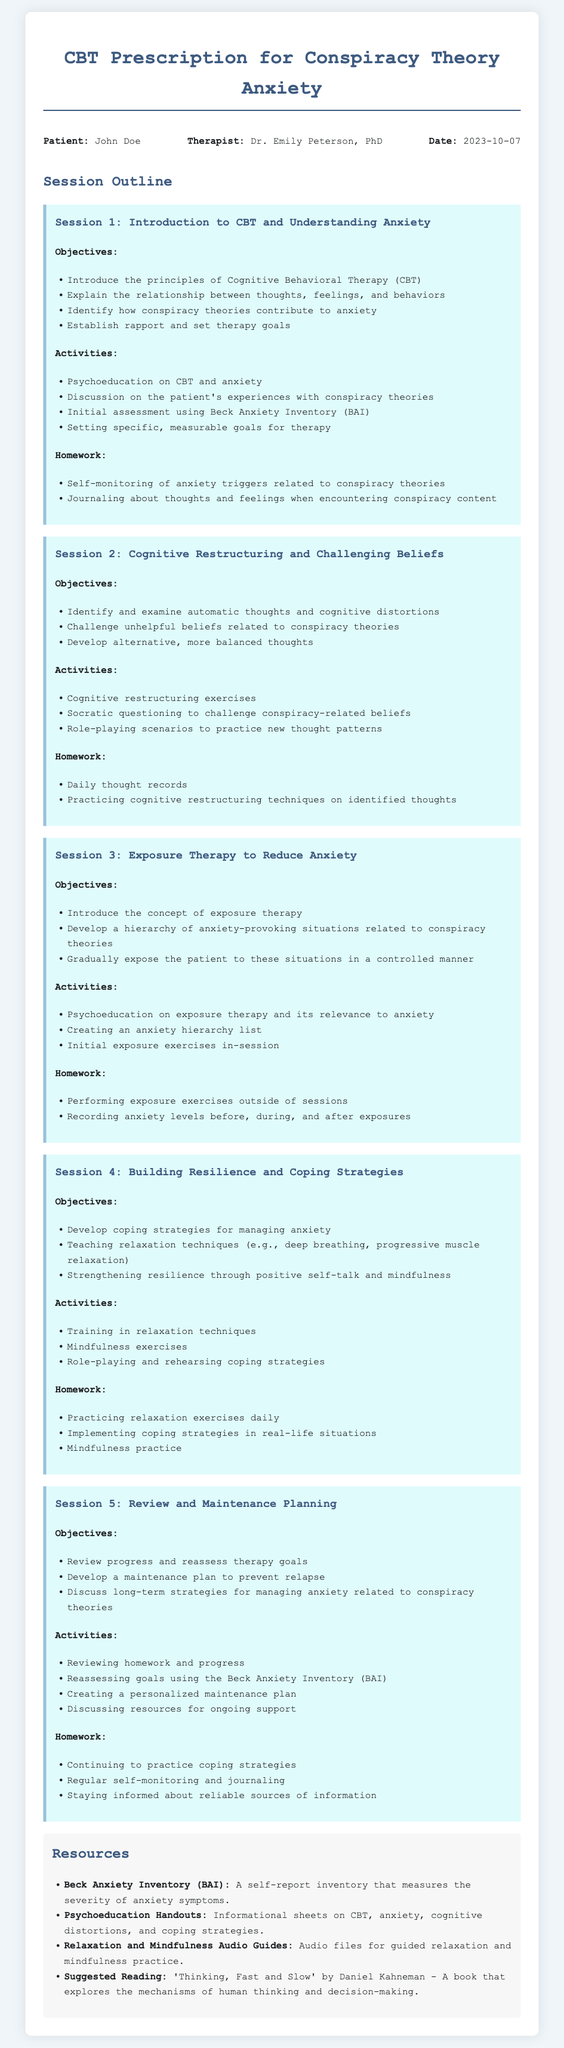What is the name of the therapist? The therapist's name is listed in the document under the header info section.
Answer: Dr. Emily Peterson, PhD What is the date of the first session? The date is provided in the header info section of the document.
Answer: 2023-10-07 What type of therapy is being prescribed? The document specifies the therapy type in the title.
Answer: Cognitive Behavioral Therapy (CBT) What inventory is used for initial assessment? The type of assessment used is mentioned in the activities of the first session.
Answer: Beck Anxiety Inventory (BAI) What is one goal of Session 2? Goals for each session are clearly outlined in the objectives section.
Answer: Challenge unhelpful beliefs related to conspiracy theories What is the main focus of Session 3? Each session's focus is detailed under the objectives section.
Answer: Exposure Therapy to Reduce Anxiety Which session involves training in relaxation techniques? The activities section of each session indicates what is covered.
Answer: Session 4 What is a resource mentioned for guided practice? The resources section lists various supportive materials.
Answer: Relaxation and Mindfulness Audio Guides What homework is assigned in Session 5? Each session outlines specific homework tasks to be completed by the patient.
Answer: Continuing to practice coping strategies 